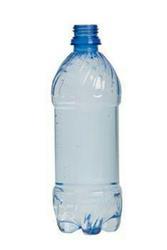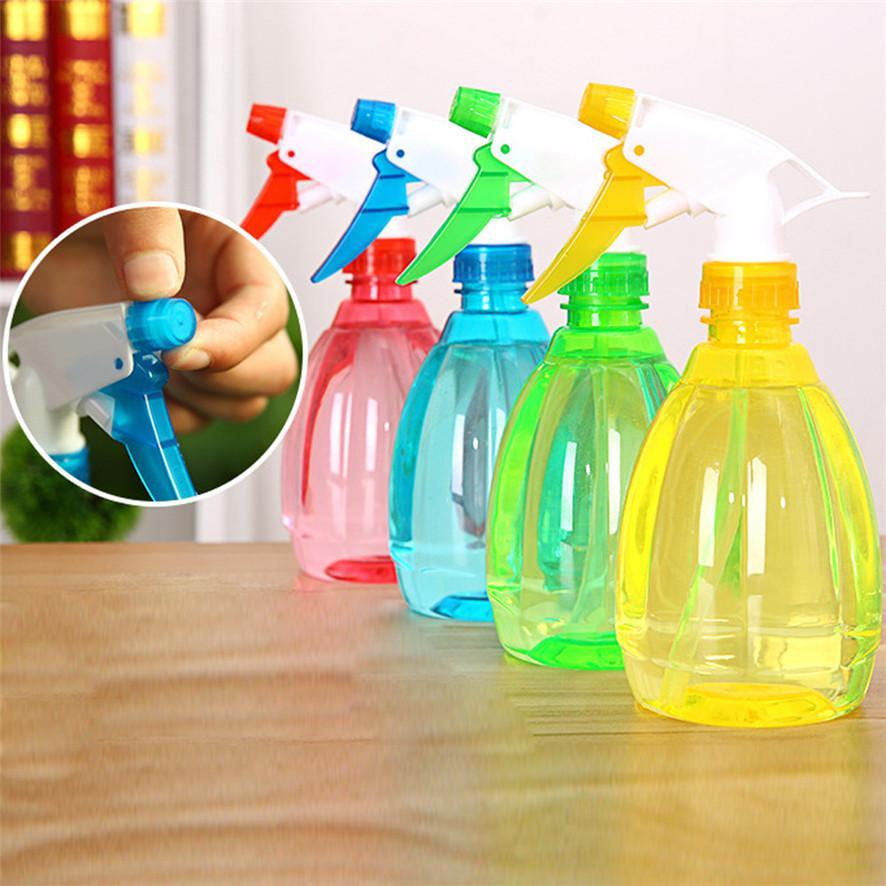The first image is the image on the left, the second image is the image on the right. For the images displayed, is the sentence "In one image, a single drinking water bottle has a blue cap and no label." factually correct? Answer yes or no. No. 